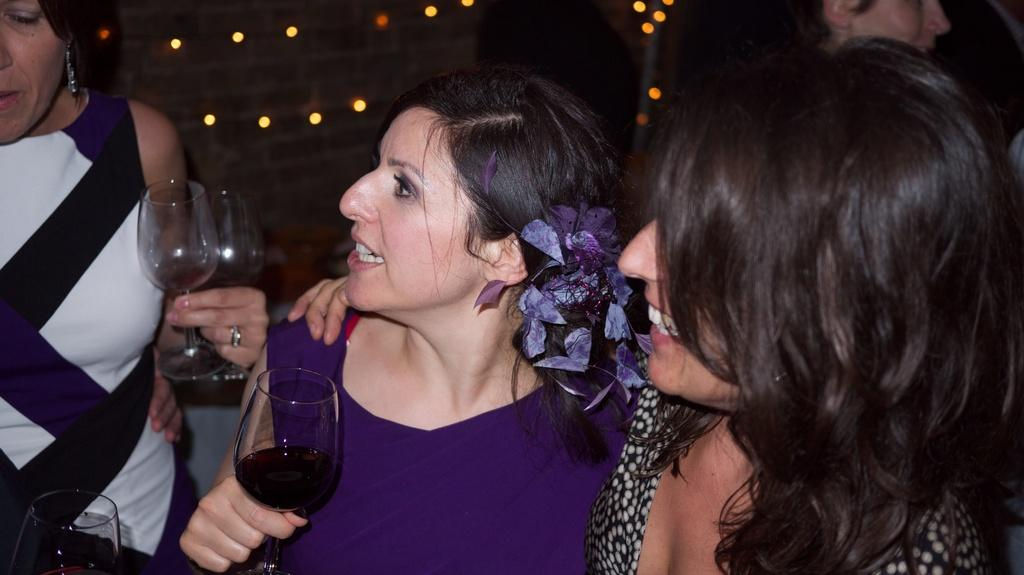How many people are in the image? There are three women in the image. What are the women holding in their hands? Each woman is holding a glass in her hand. What type of cabbage is being served on the plate in the image? There is no plate or cabbage present in the image; the women are holding glasses. 